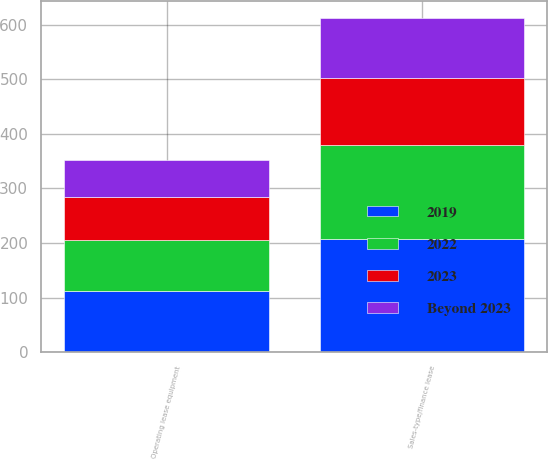<chart> <loc_0><loc_0><loc_500><loc_500><stacked_bar_chart><ecel><fcel>Sales-type/finance lease<fcel>Operating lease equipment<nl><fcel>2019<fcel>208<fcel>112<nl><fcel>2022<fcel>171<fcel>93<nl><fcel>2023<fcel>124<fcel>79<nl><fcel>Beyond 2023<fcel>110<fcel>68<nl></chart> 